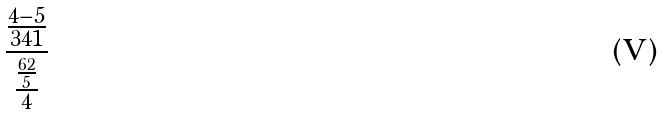Convert formula to latex. <formula><loc_0><loc_0><loc_500><loc_500>\frac { \frac { 4 - 5 } { 3 4 1 } } { \frac { \frac { 6 2 } { 5 } } { 4 } }</formula> 